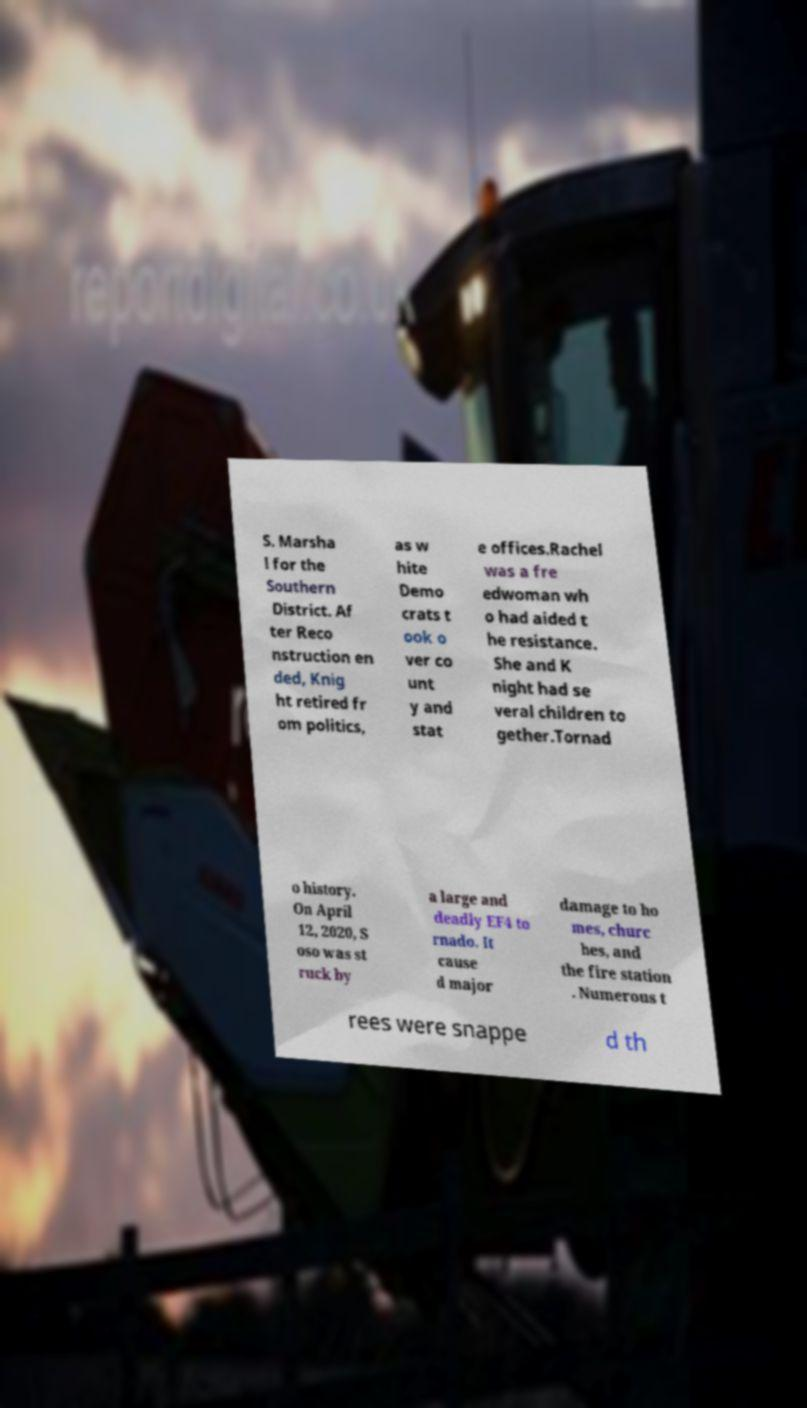There's text embedded in this image that I need extracted. Can you transcribe it verbatim? S. Marsha l for the Southern District. Af ter Reco nstruction en ded, Knig ht retired fr om politics, as w hite Demo crats t ook o ver co unt y and stat e offices.Rachel was a fre edwoman wh o had aided t he resistance. She and K night had se veral children to gether.Tornad o history. On April 12, 2020, S oso was st ruck by a large and deadly EF4 to rnado. It cause d major damage to ho mes, churc hes, and the fire station . Numerous t rees were snappe d th 